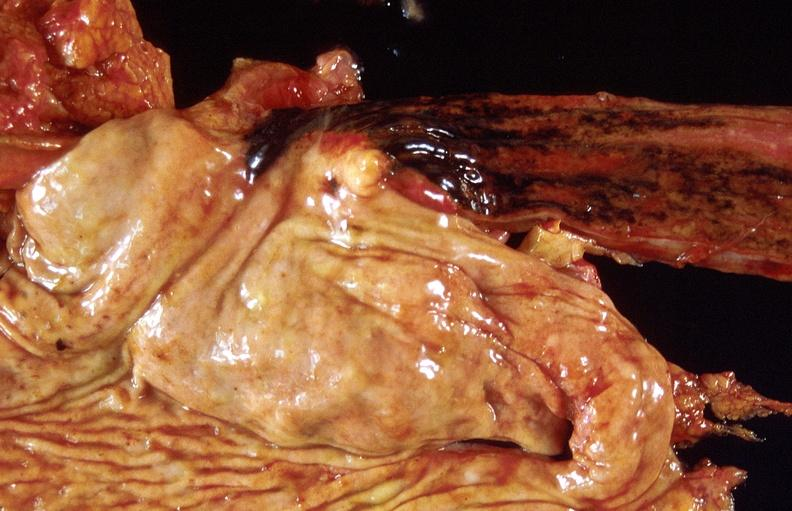s previous slide from this case present?
Answer the question using a single word or phrase. No 